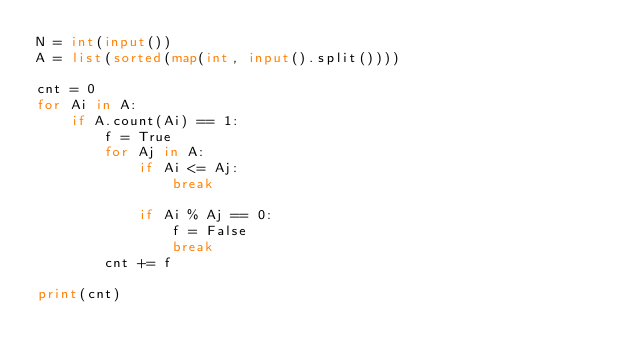Convert code to text. <code><loc_0><loc_0><loc_500><loc_500><_Python_>N = int(input())
A = list(sorted(map(int, input().split())))

cnt = 0
for Ai in A:
    if A.count(Ai) == 1:
        f = True
        for Aj in A:
            if Ai <= Aj:
                break

            if Ai % Aj == 0:
                f = False
                break
        cnt += f

print(cnt)</code> 